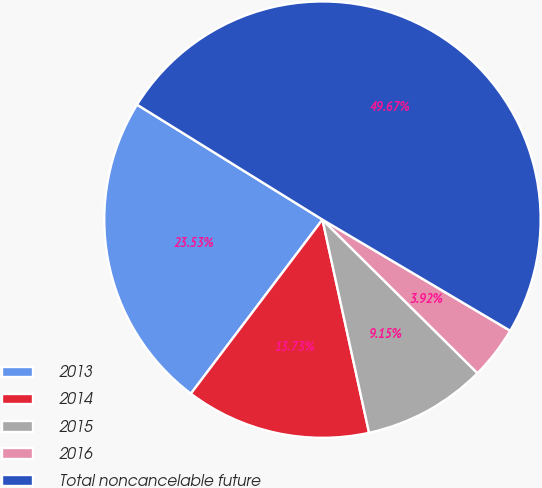<chart> <loc_0><loc_0><loc_500><loc_500><pie_chart><fcel>2013<fcel>2014<fcel>2015<fcel>2016<fcel>Total noncancelable future<nl><fcel>23.53%<fcel>13.73%<fcel>9.15%<fcel>3.92%<fcel>49.67%<nl></chart> 